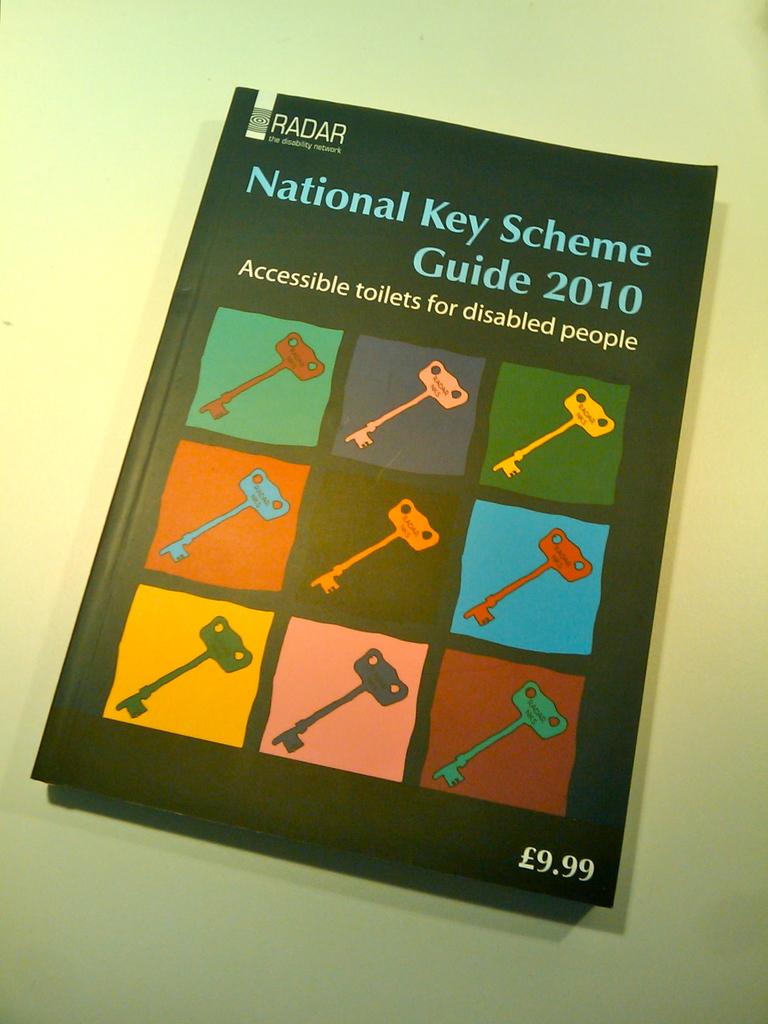What is the purpose of this book?
Keep it short and to the point. Accessible toilets for disabled people. 